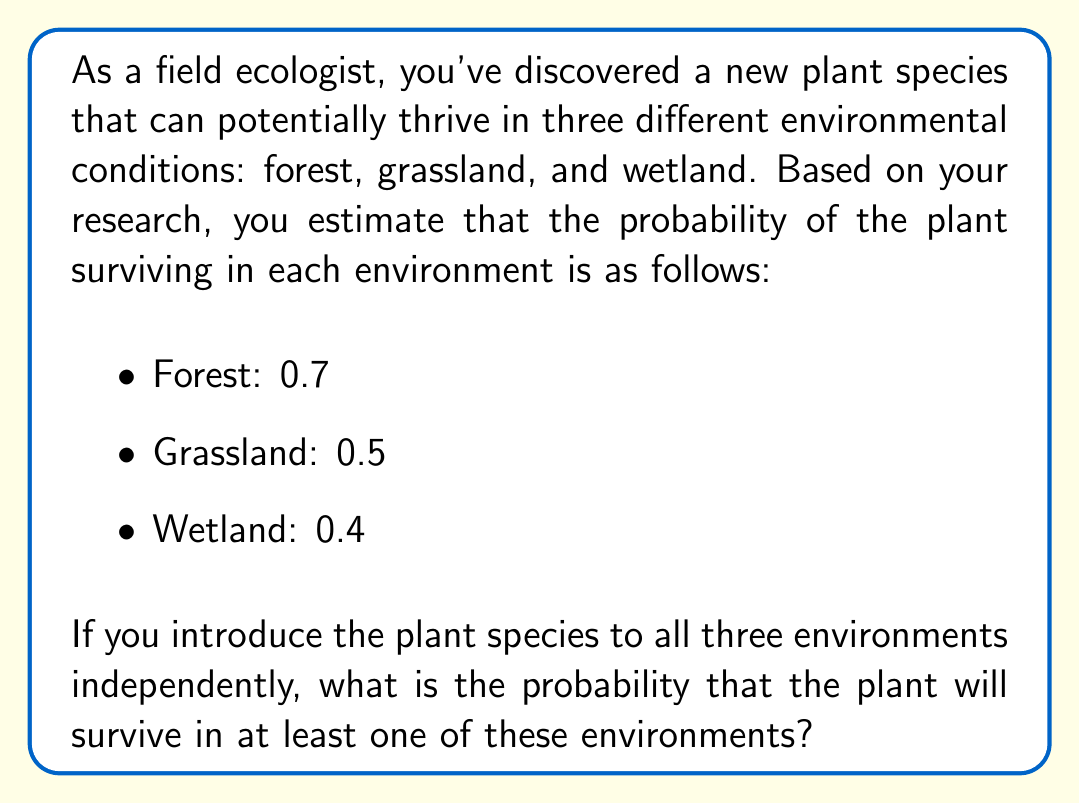What is the answer to this math problem? To solve this problem, we'll use the complement of the probability that the plant fails to survive in all three environments. Here's the step-by-step solution:

1) First, let's calculate the probability of the plant not surviving in each environment:
   - Forest: $1 - 0.7 = 0.3$
   - Grassland: $1 - 0.5 = 0.5$
   - Wetland: $1 - 0.4 = 0.6$

2) The probability of the plant not surviving in any of the environments is the product of these probabilities, as the events are independent:

   $P(\text{not surviving anywhere}) = 0.3 \times 0.5 \times 0.6 = 0.09$

3) The probability of surviving in at least one environment is the complement of not surviving anywhere:

   $P(\text{surviving in at least one}) = 1 - P(\text{not surviving anywhere})$
   
   $= 1 - 0.09 = 0.91$

Therefore, the probability that the plant will survive in at least one of these environments is 0.91 or 91%.
Answer: 0.91 